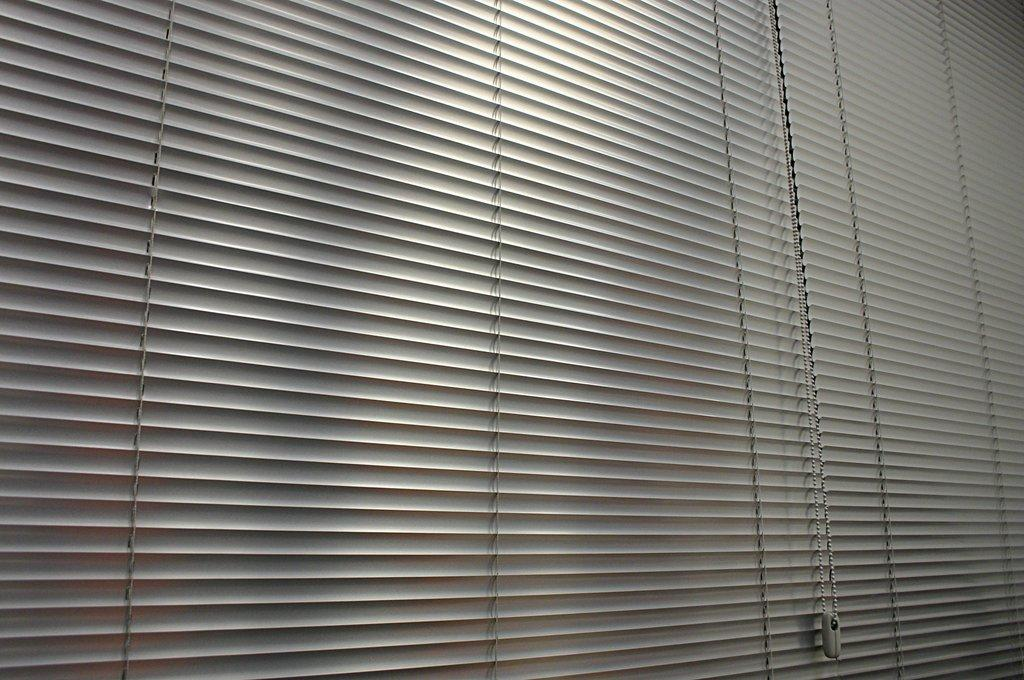What type of window treatment is present in the image? There are roller blinds in the image. What color are the roller blinds? The roller blinds are off-white in color. What is the profit margin of the drain in the image? There is no drain present in the image, and therefore no profit margin can be determined. 